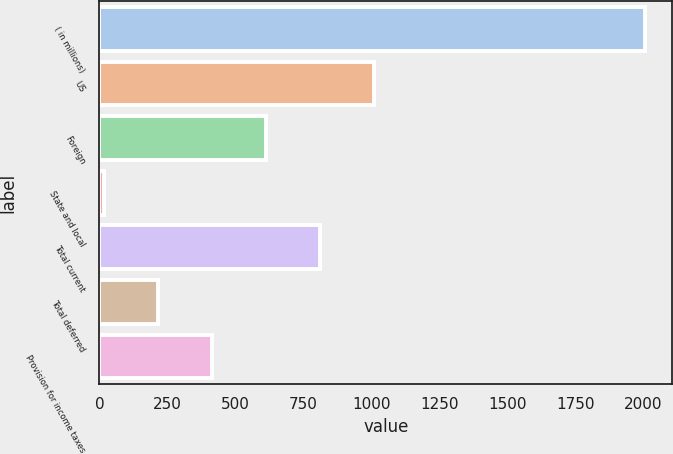<chart> <loc_0><loc_0><loc_500><loc_500><bar_chart><fcel>( in millions)<fcel>US<fcel>Foreign<fcel>State and local<fcel>Total current<fcel>Total deferred<fcel>Provision for income taxes<nl><fcel>2005<fcel>1010.15<fcel>612.21<fcel>15.3<fcel>811.18<fcel>214.27<fcel>413.24<nl></chart> 